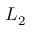Convert formula to latex. <formula><loc_0><loc_0><loc_500><loc_500>L _ { 2 }</formula> 